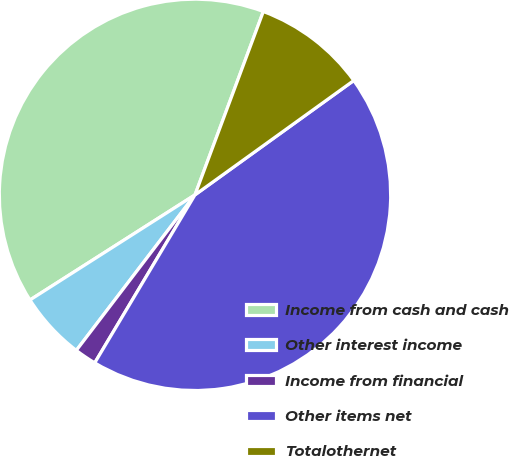Convert chart to OTSL. <chart><loc_0><loc_0><loc_500><loc_500><pie_chart><fcel>Income from cash and cash<fcel>Other interest income<fcel>Income from financial<fcel>Other items net<fcel>Totalothernet<nl><fcel>39.71%<fcel>5.6%<fcel>1.81%<fcel>43.5%<fcel>9.39%<nl></chart> 